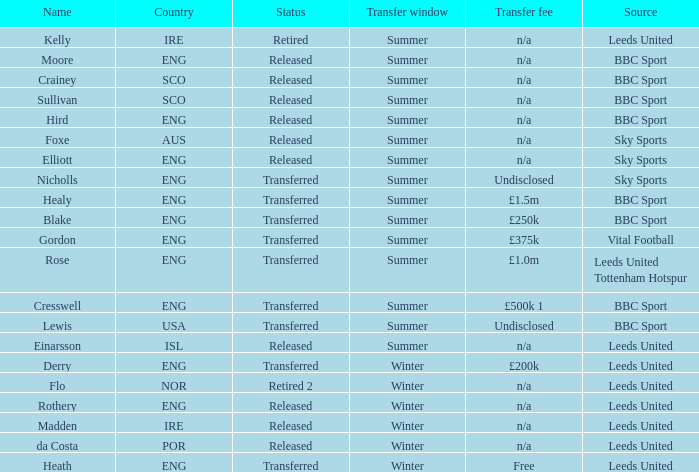What was the cost of the summer transfer for the sco athlete known as crainey? N/a. 